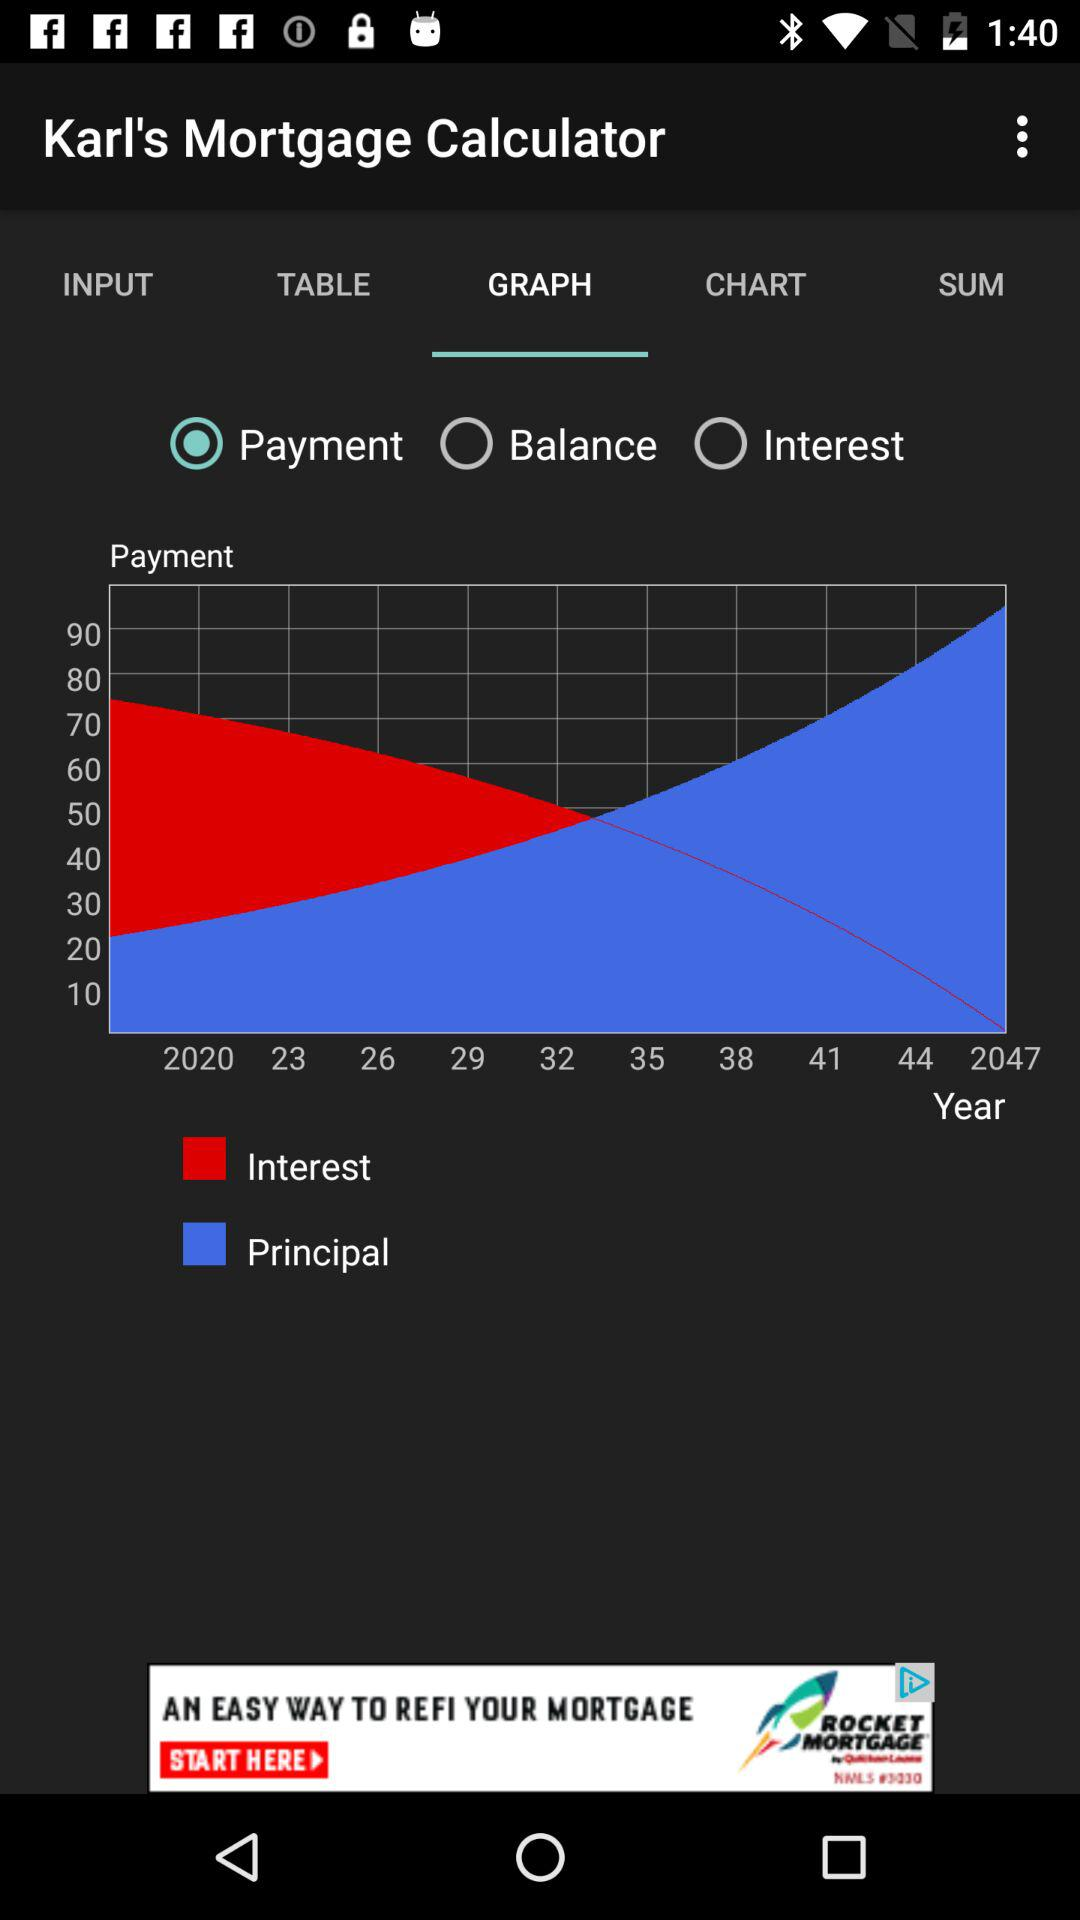What is the calculator name? The calculator name is "Karl's Mortgage Calculator". 